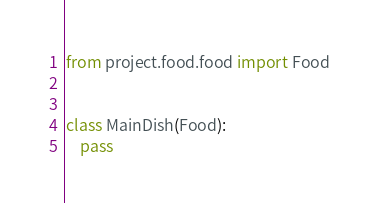<code> <loc_0><loc_0><loc_500><loc_500><_Python_>from project.food.food import Food


class MainDish(Food):
    pass
</code> 